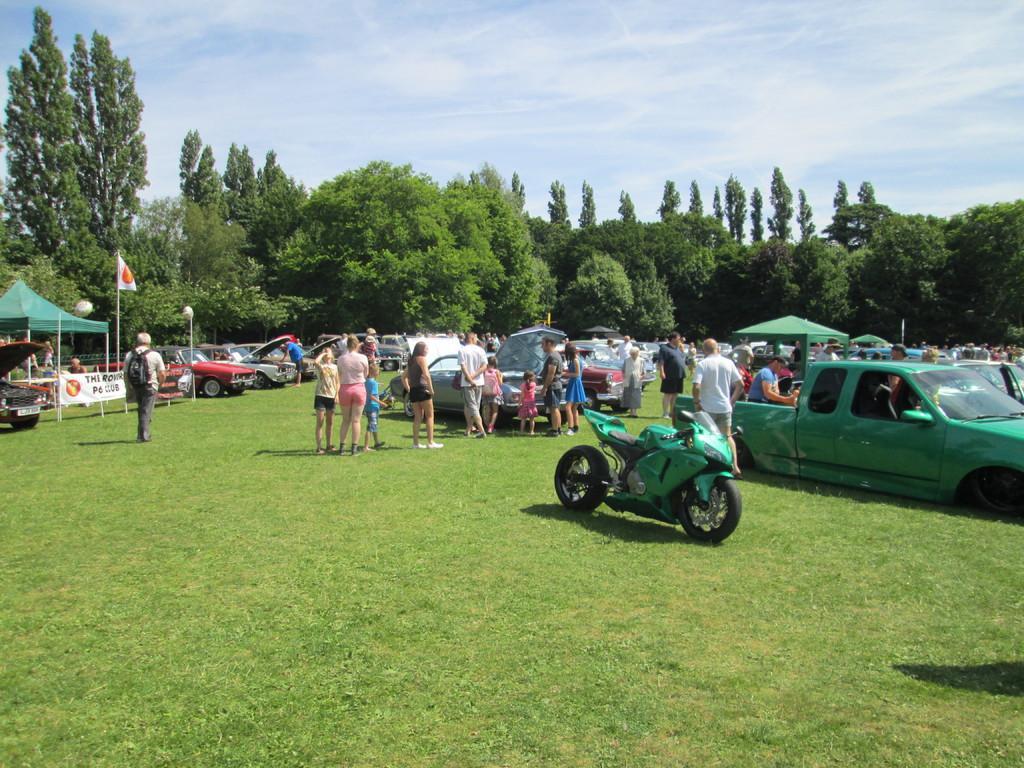Describe this image in one or two sentences. These are the cars and a motorbike, which are parked. There are groups of people standing. I can see the canopy tents. This is a flag hanging to the pole. I can see a banner. These are the trees. Here is the grass. 